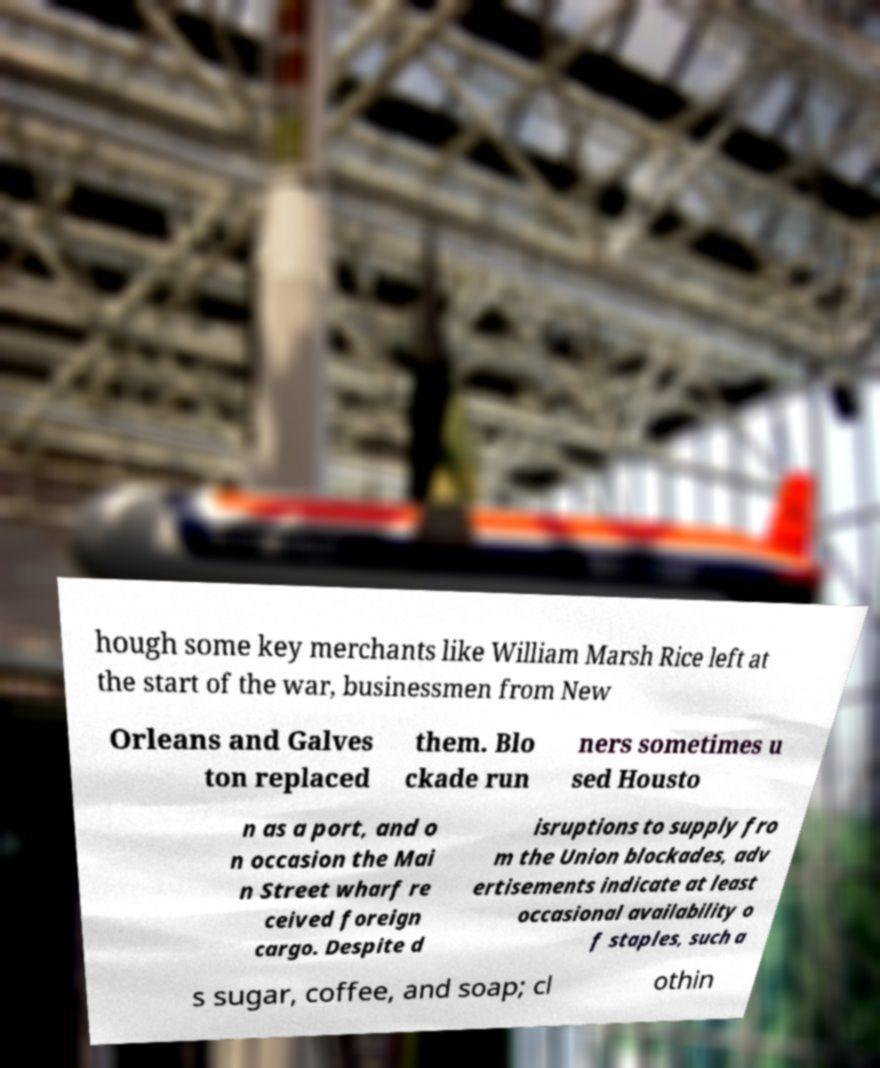Can you read and provide the text displayed in the image?This photo seems to have some interesting text. Can you extract and type it out for me? hough some key merchants like William Marsh Rice left at the start of the war, businessmen from New Orleans and Galves ton replaced them. Blo ckade run ners sometimes u sed Housto n as a port, and o n occasion the Mai n Street wharf re ceived foreign cargo. Despite d isruptions to supply fro m the Union blockades, adv ertisements indicate at least occasional availability o f staples, such a s sugar, coffee, and soap; cl othin 